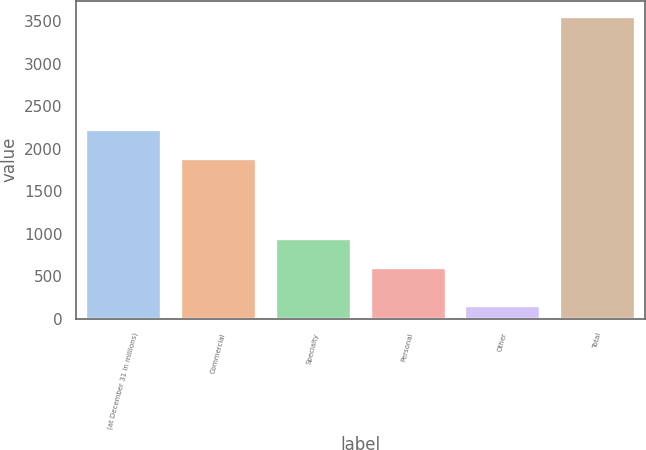<chart> <loc_0><loc_0><loc_500><loc_500><bar_chart><fcel>(at December 31 in millions)<fcel>Commercial<fcel>Specialty<fcel>Personal<fcel>Other<fcel>Total<nl><fcel>2233.6<fcel>1893<fcel>953.6<fcel>613<fcel>158<fcel>3564<nl></chart> 